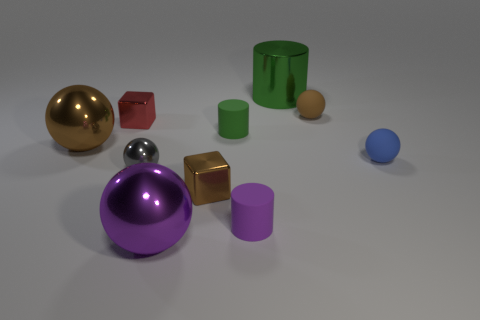What is the material of the cube in front of the small ball that is on the left side of the tiny purple matte thing?
Keep it short and to the point. Metal. Are there any other small spheres of the same color as the small metal ball?
Your response must be concise. No. There is a gray sphere that is the same material as the purple sphere; what is its size?
Ensure brevity in your answer.  Small. Is there any other thing that is the same color as the big metal cylinder?
Provide a short and direct response. Yes. There is a large thing that is in front of the big brown metallic object; what is its color?
Give a very brief answer. Purple. There is a large green metallic cylinder behind the tiny object that is behind the red block; are there any small gray things that are behind it?
Ensure brevity in your answer.  No. Is the number of brown metallic cubes that are on the left side of the tiny gray shiny thing greater than the number of green objects?
Offer a very short reply. No. There is a shiny thing behind the small red block; does it have the same shape as the red object?
Provide a succinct answer. No. Are there any other things that are made of the same material as the big brown thing?
Offer a very short reply. Yes. What number of things are small cylinders or shiny objects right of the red metal block?
Your response must be concise. 6. 